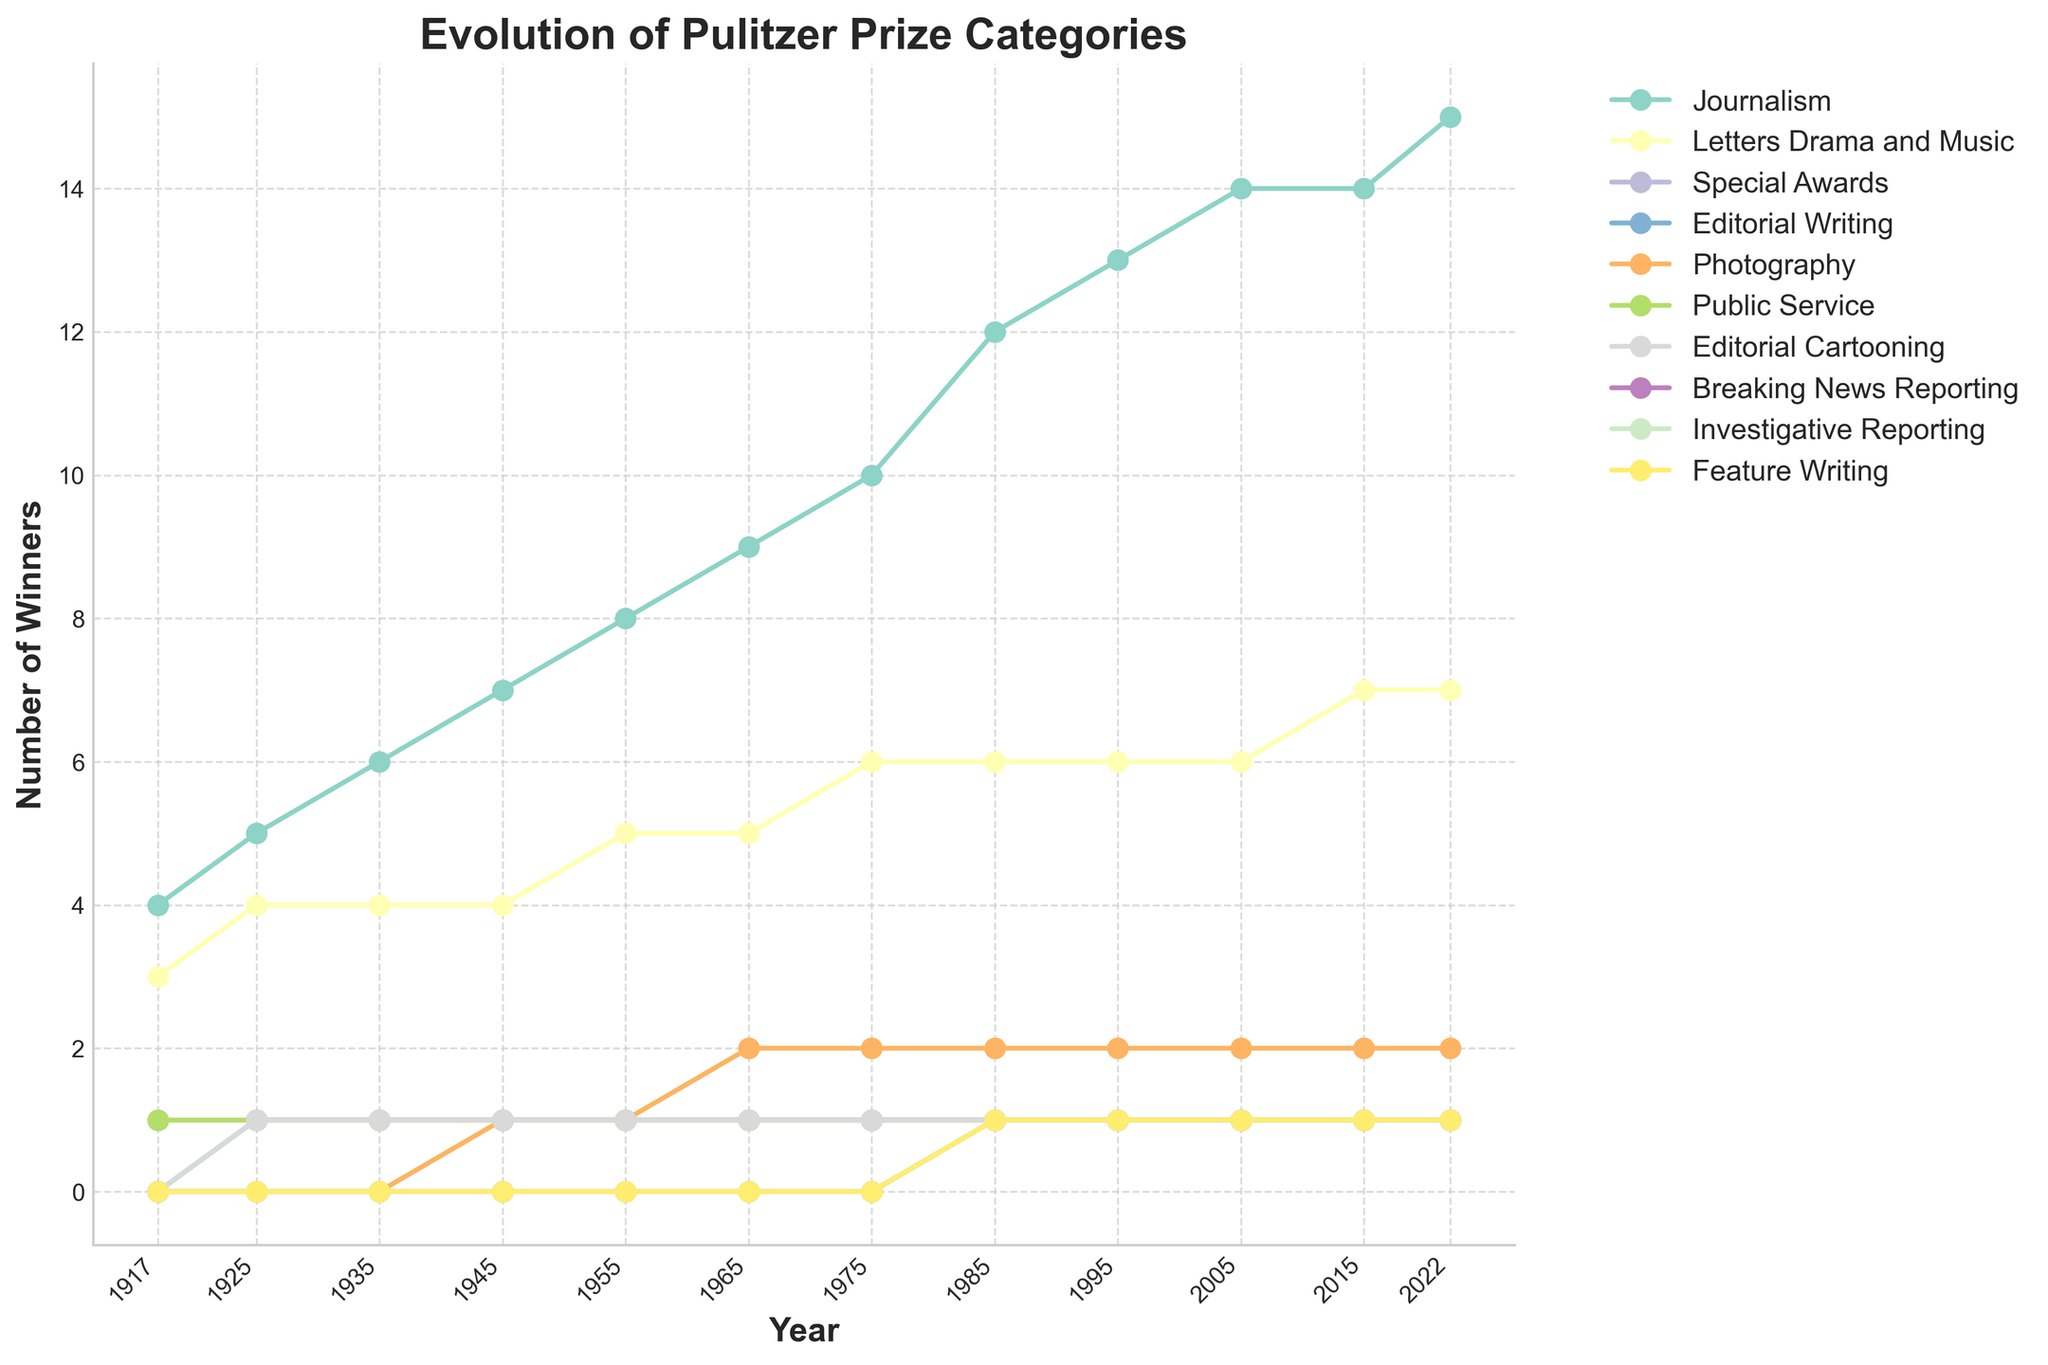What is the total number of Pulitzer Prize winners in the year 2022? To find the total number of Pulitzer Prize winners in 2022, sum up the values for all categories in that particular year: 15 (Journalism) + 7 (Letters Drama and Music) + 1 (Special Awards) + 1 (Editorial Writing) + 2 (Photography) + 1 (Public Service) + 1 (Editorial Cartooning) + 1 (Breaking News Reporting) + 1 (Investigative Reporting) + 1 (Feature Writing) = 31.
Answer: 31 Which category has the most winners in 2022 and what is the count? Look at the year 2022 and compare the values across all categories. Journalism has the highest count of winners which is 15.
Answer: Journalism, 15 How has the number of Journalism winners changed from 1917 to 2022? Identify the values for Journalism in 1917 and 2022 from the chart. In 1917, Journalism had 4 winners, and by 2022 it increased to 15 winners. The change is 15 - 4 = 11.
Answer: Increased by 11 What’s the first year when “Photography” had more than 1 winner? Review the historical data given for the Photography category for each year. The first year to have more than 1 winner in Photography is 1965 with a count of 2.
Answer: 1965 Compare the number of winners in "Letters Drama and Music" and "Public Service" in 1955. Which category had more winners and by how much? For the year 1955: Letters Drama and Music had 5 winners, and Public Service had 1 winner. The difference is 5 - 1 = 4. Thus, Letters Drama and Music had 4 more winners than Public Service.
Answer: Letters Drama and Music, 4 During which years did the "Breaking News Reporting" category first appear and how many winners were there? Breaking News Reporting first appears in 1985. The chart shows 1 winner for Breaking News Reporting in 1985.
Answer: 1985, 1 What is the trend for the "Special Awards" category from 1917 to 2022? From the visual, the Special Awards category stays constant with 1 winner every year from 1917 to 2022.
Answer: Constant with 1 winner Does the "Editorial Cartooning" category ever exceed 1 winner between 1917 and 2022? By scanning through the values in the chart for Editorial Cartooning from 1917 to 2022, it consistently shows 1 winner each year.
Answer: No What's the sum of winners in the categories "Investigative Reporting" and "Feature Writing" in 2005? Look at the winners in 2005 for Investigative Reporting and Feature Writing. Both categories have 1 winner each. So, 1 (Investigative Reporting) + 1 (Feature Writing) = 2.
Answer: 2 How many categories had exactly 1 winner in 1945? For 1945, check all categories and count how many have exactly 1 winner: Special Awards (1), Editorial Writing (1), Public Service (1), Editorial Cartooning (1). That's 4 categories.
Answer: 4 